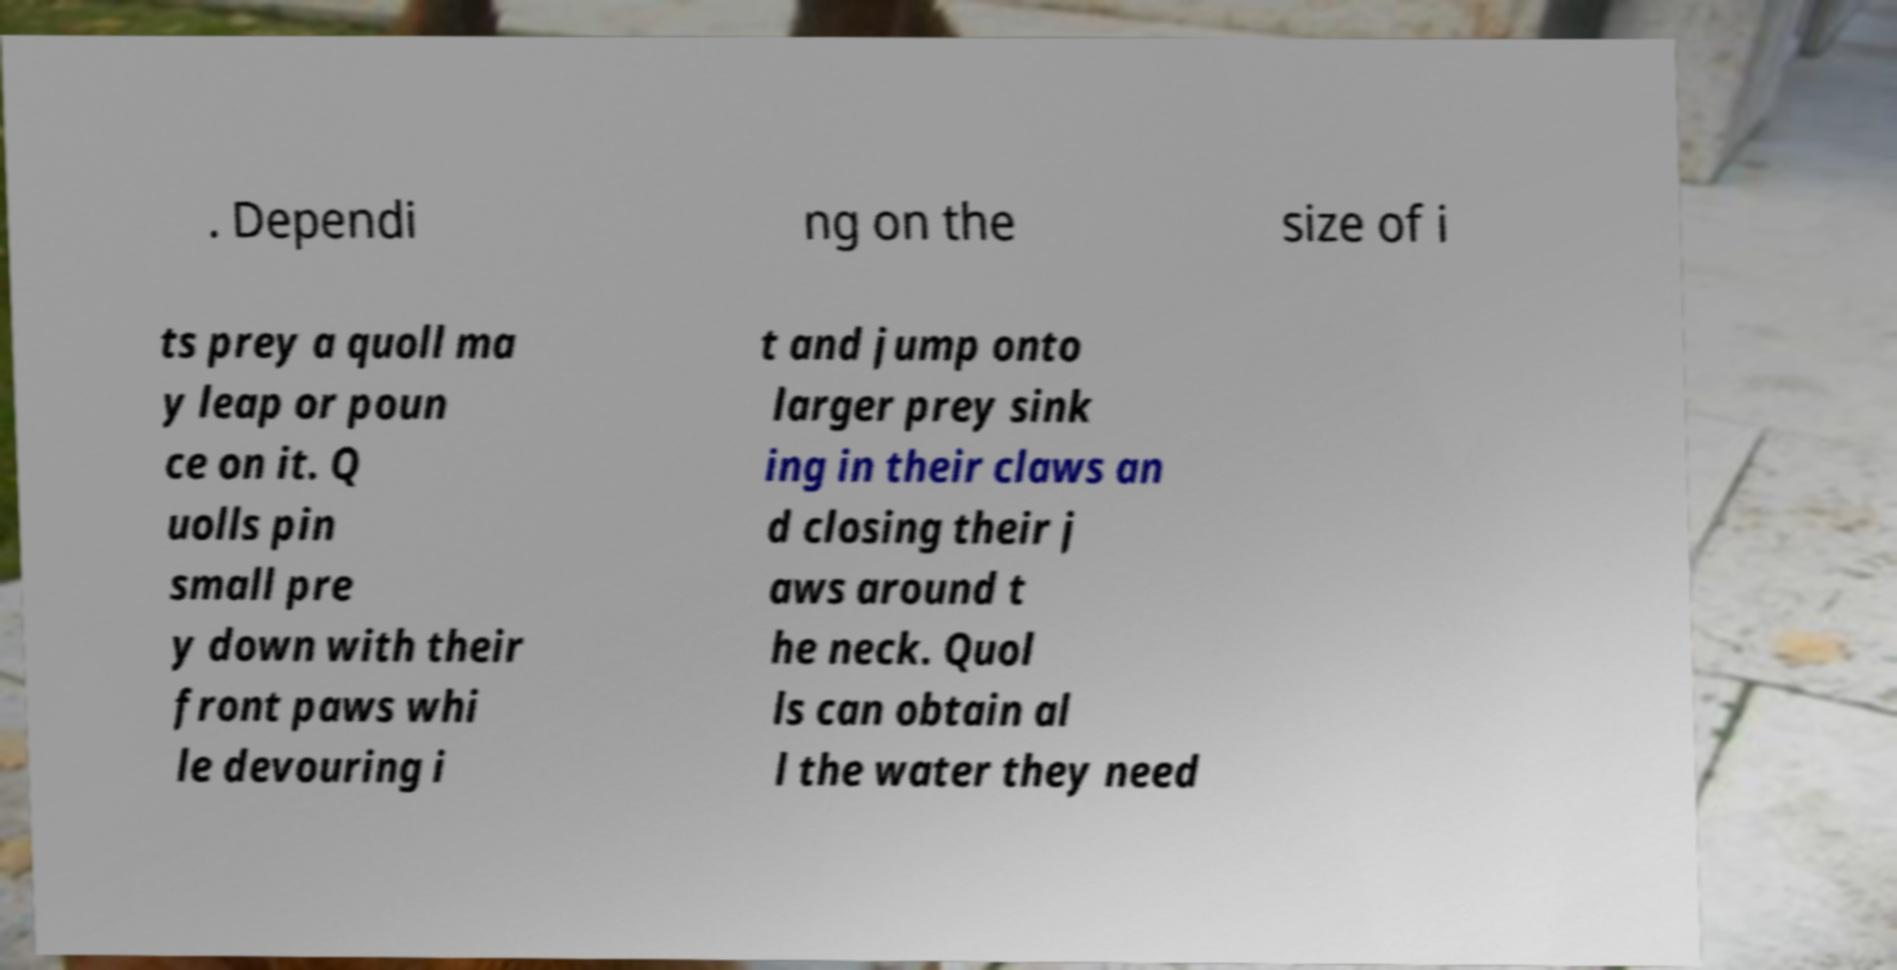Could you extract and type out the text from this image? . Dependi ng on the size of i ts prey a quoll ma y leap or poun ce on it. Q uolls pin small pre y down with their front paws whi le devouring i t and jump onto larger prey sink ing in their claws an d closing their j aws around t he neck. Quol ls can obtain al l the water they need 